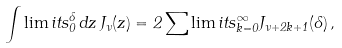<formula> <loc_0><loc_0><loc_500><loc_500>\int \lim i t s _ { 0 } ^ { \Lambda } \, d z \, J _ { \nu } ( z ) = 2 \sum \lim i t s _ { k = 0 } ^ { \infty } J _ { \nu + 2 k + 1 } ( \Lambda ) \, ,</formula> 